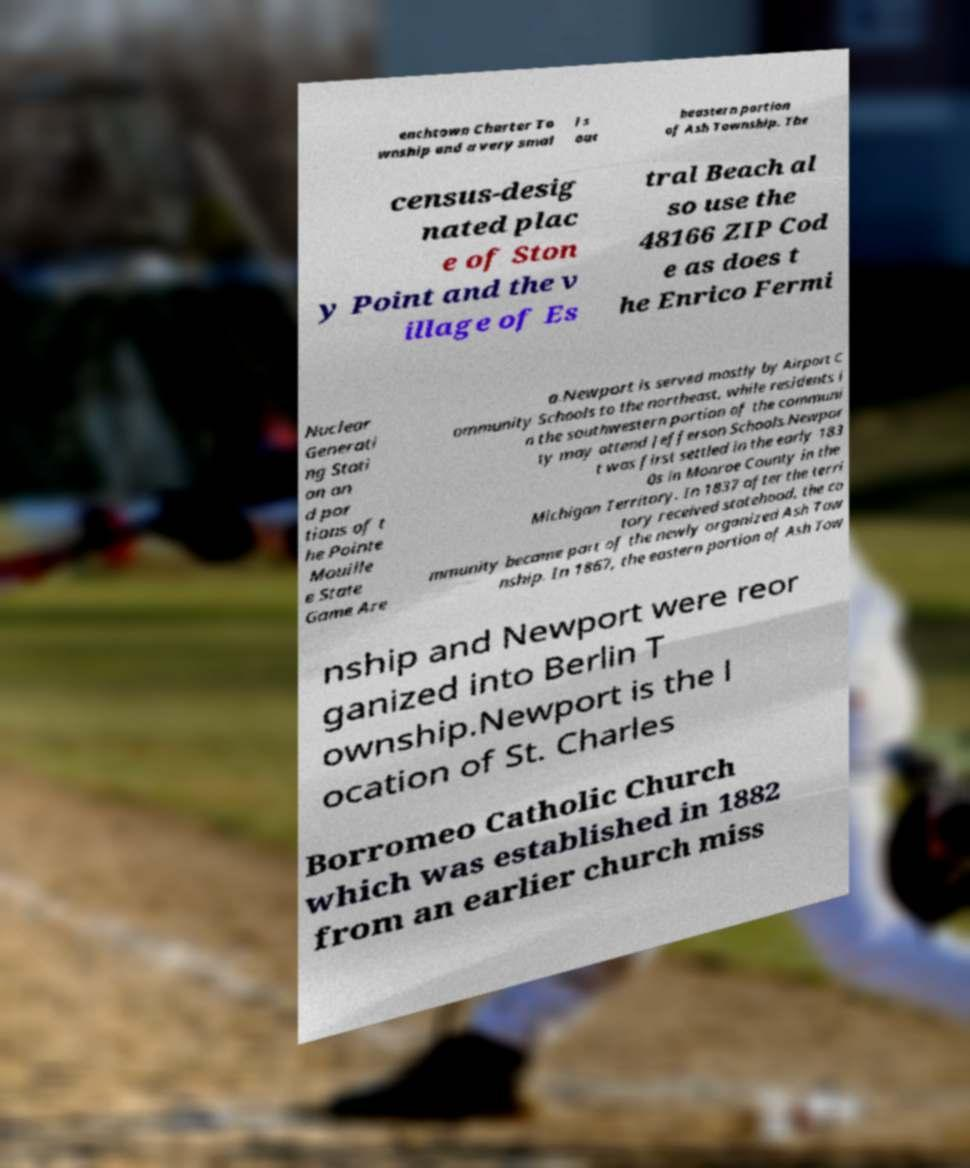Can you accurately transcribe the text from the provided image for me? enchtown Charter To wnship and a very smal l s out heastern portion of Ash Township. The census-desig nated plac e of Ston y Point and the v illage of Es tral Beach al so use the 48166 ZIP Cod e as does t he Enrico Fermi Nuclear Generati ng Stati on an d por tions of t he Pointe Mouille e State Game Are a.Newport is served mostly by Airport C ommunity Schools to the northeast, while residents i n the southwestern portion of the communi ty may attend Jefferson Schools.Newpor t was first settled in the early 183 0s in Monroe County in the Michigan Territory. In 1837 after the terri tory received statehood, the co mmunity became part of the newly organized Ash Tow nship. In 1867, the eastern portion of Ash Tow nship and Newport were reor ganized into Berlin T ownship.Newport is the l ocation of St. Charles Borromeo Catholic Church which was established in 1882 from an earlier church miss 